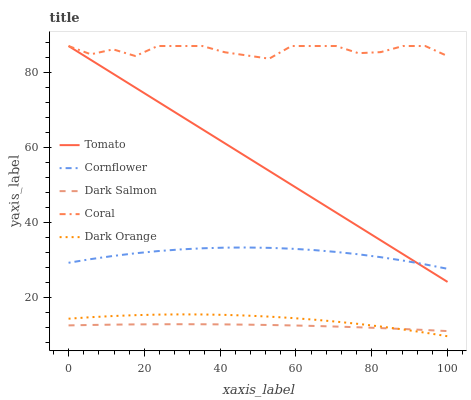Does Dark Salmon have the minimum area under the curve?
Answer yes or no. Yes. Does Coral have the maximum area under the curve?
Answer yes or no. Yes. Does Cornflower have the minimum area under the curve?
Answer yes or no. No. Does Cornflower have the maximum area under the curve?
Answer yes or no. No. Is Tomato the smoothest?
Answer yes or no. Yes. Is Coral the roughest?
Answer yes or no. Yes. Is Cornflower the smoothest?
Answer yes or no. No. Is Cornflower the roughest?
Answer yes or no. No. Does Dark Orange have the lowest value?
Answer yes or no. Yes. Does Cornflower have the lowest value?
Answer yes or no. No. Does Coral have the highest value?
Answer yes or no. Yes. Does Cornflower have the highest value?
Answer yes or no. No. Is Dark Salmon less than Coral?
Answer yes or no. Yes. Is Coral greater than Dark Orange?
Answer yes or no. Yes. Does Coral intersect Tomato?
Answer yes or no. Yes. Is Coral less than Tomato?
Answer yes or no. No. Is Coral greater than Tomato?
Answer yes or no. No. Does Dark Salmon intersect Coral?
Answer yes or no. No. 